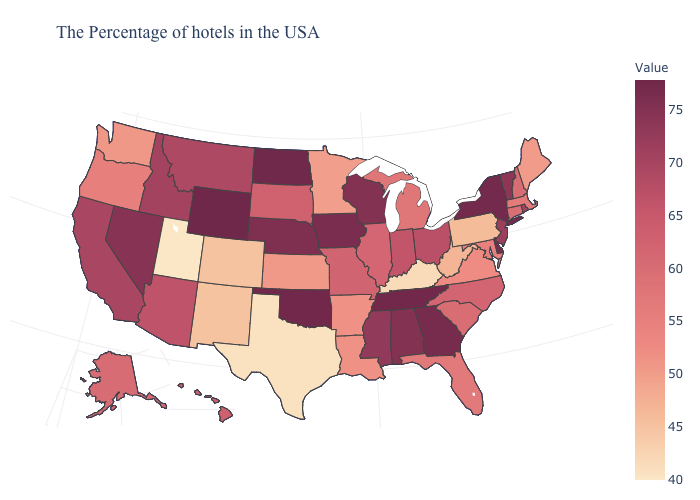Among the states that border New Hampshire , does Maine have the highest value?
Answer briefly. No. Does the map have missing data?
Write a very short answer. No. Which states have the lowest value in the USA?
Quick response, please. Utah. Is the legend a continuous bar?
Short answer required. Yes. 